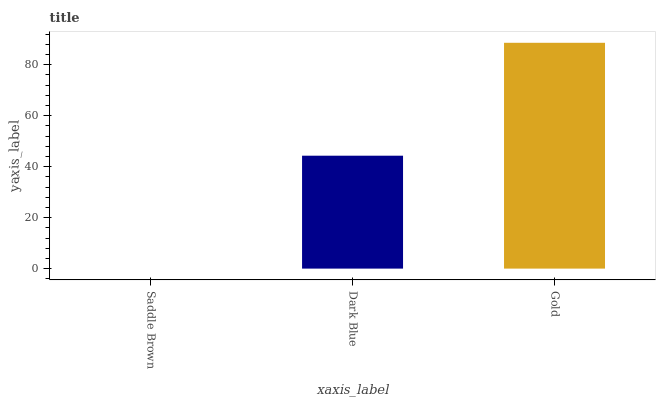Is Saddle Brown the minimum?
Answer yes or no. Yes. Is Gold the maximum?
Answer yes or no. Yes. Is Dark Blue the minimum?
Answer yes or no. No. Is Dark Blue the maximum?
Answer yes or no. No. Is Dark Blue greater than Saddle Brown?
Answer yes or no. Yes. Is Saddle Brown less than Dark Blue?
Answer yes or no. Yes. Is Saddle Brown greater than Dark Blue?
Answer yes or no. No. Is Dark Blue less than Saddle Brown?
Answer yes or no. No. Is Dark Blue the high median?
Answer yes or no. Yes. Is Dark Blue the low median?
Answer yes or no. Yes. Is Saddle Brown the high median?
Answer yes or no. No. Is Saddle Brown the low median?
Answer yes or no. No. 